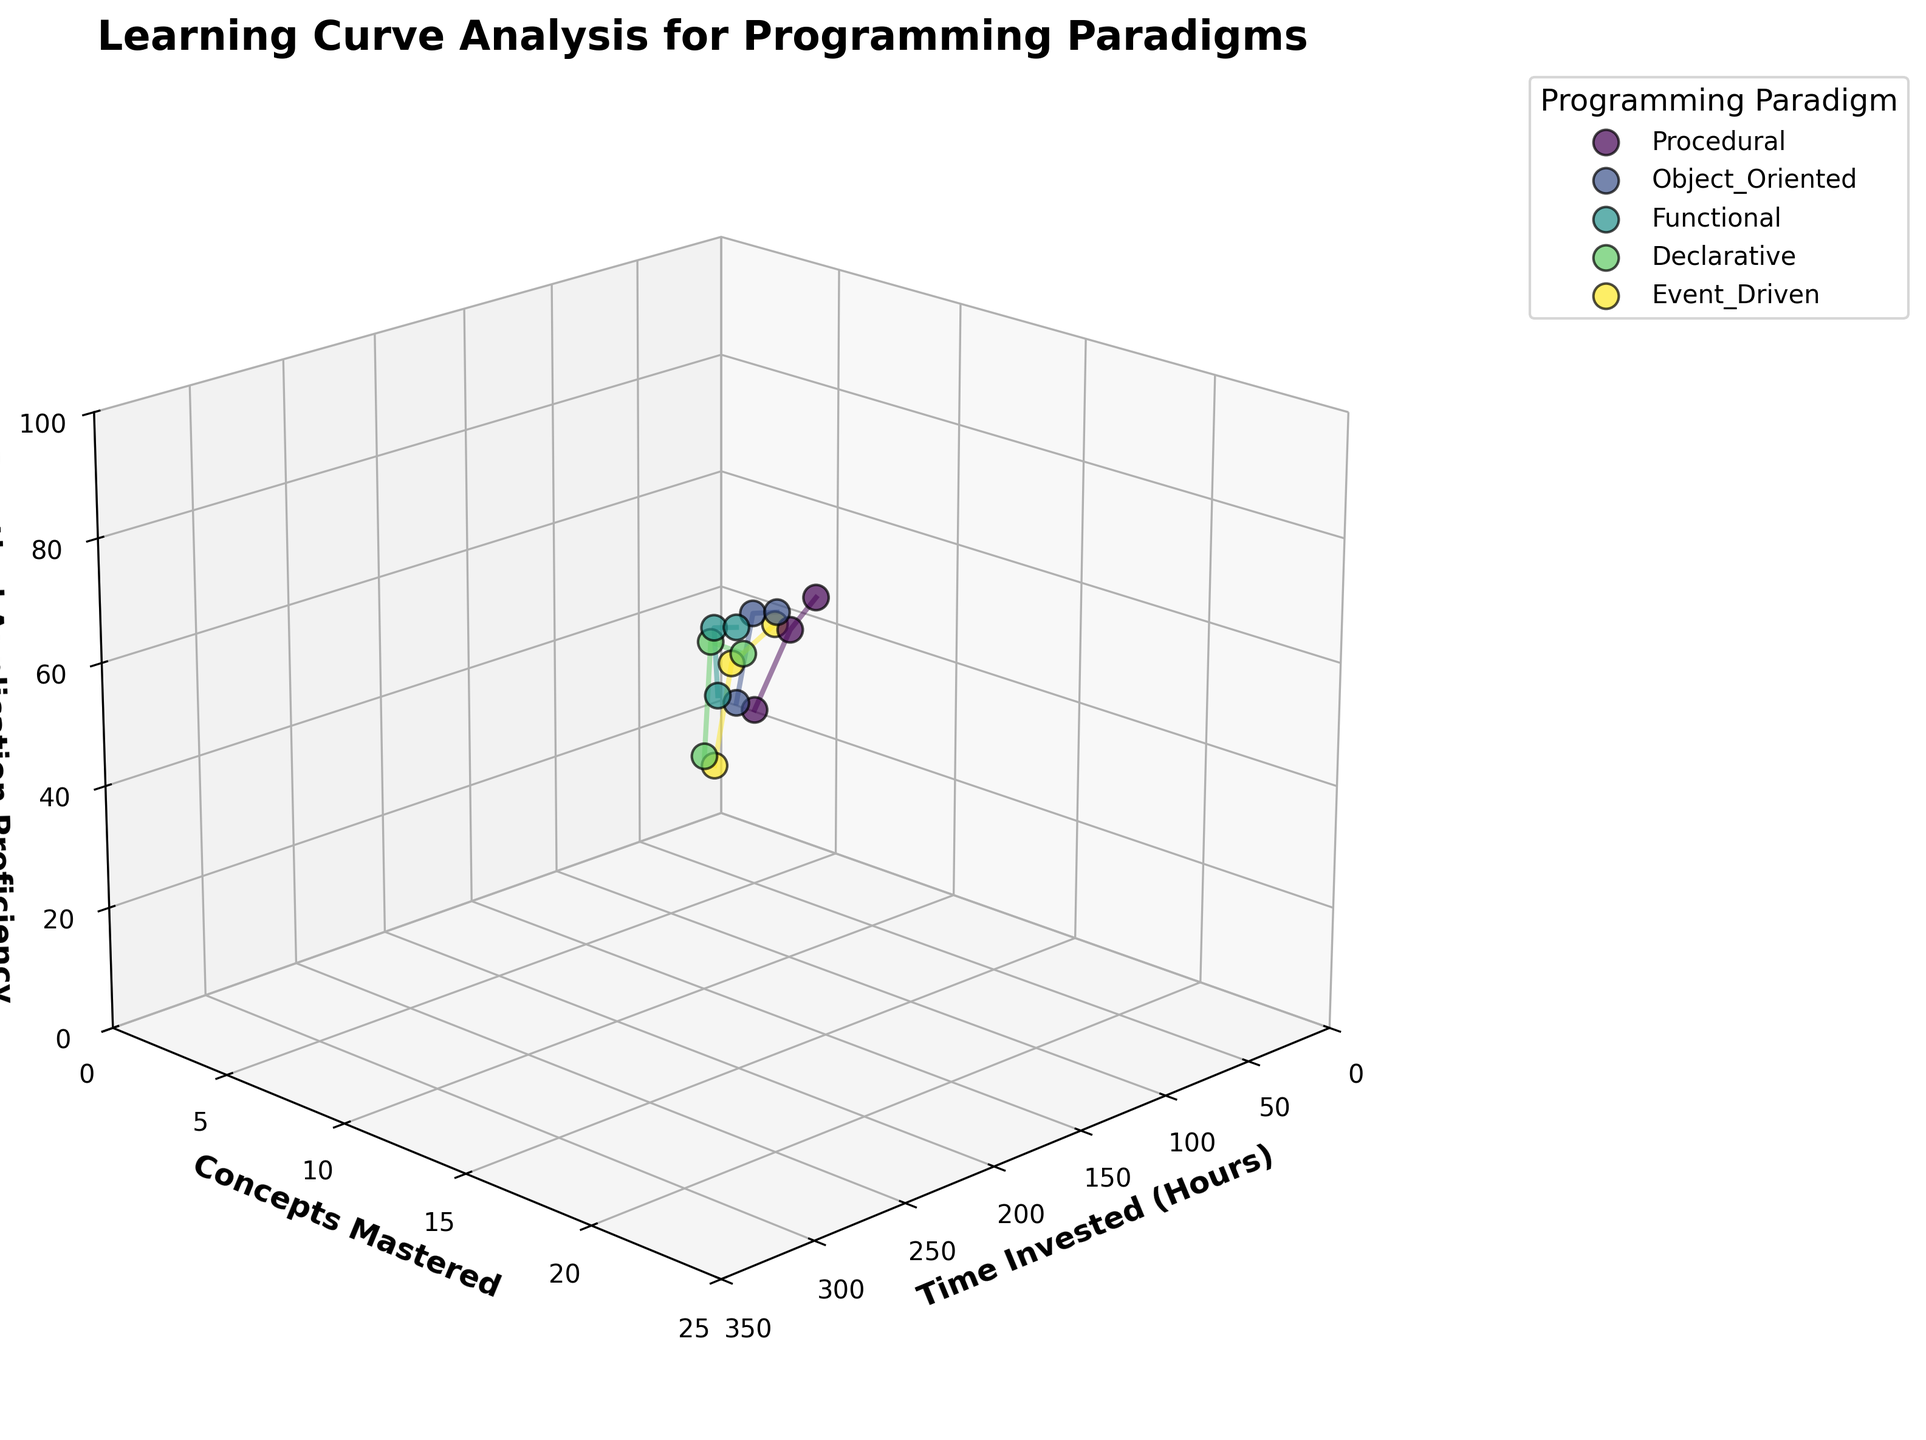What is the title of the figure? The title of the figure is displayed at the top of the 3D plot.
Answer: Learning Curve Analysis for Programming Paradigms What are the axis labels in the figure? The axes labels are displayed below and beside each axis. The x-axis is labeled "Time Invested (Hours)", the y-axis is labeled "Concepts Mastered", and the z-axis is labeled "Practical Application Proficiency".
Answer: Time Invested (Hours), Concepts Mastered, Practical Application Proficiency Which programming paradigm reached the highest practical application proficiency? Look at the z-axis values where the dots are positioned highest. The paradigm that reaches the highest value on this axis is the one with the highest practical application proficiency.
Answer: Functional How many data points are plotted for the Object-Oriented programming paradigm? Count the number of data points (or dots) associated with the Object-Oriented programming paradigm. Each dot represents a data point.
Answer: 3 What is the practical application proficiency for the Procedural paradigm when 100 hours are invested? Locate the Procedural paradigm data points and find the one that corresponds to 100 hours on the x-axis. Read the corresponding z-axis (Practical Application Proficiency) value.
Answer: 55 Compare the concepts mastered between the Declarative and Event-Driven paradigms at their final data points. Which paradigm mastered more concepts? Look at the final data point (highest x-axis value) for each paradigm and compare the y-axis (Concepts Mastered) values.
Answer: Declarative What is the difference in practical application proficiency between Functional and Procedural paradigms when 200 hours are invested? Identify the data points for Functional and Procedural paradigms at 200 hours on the x-axis and subtract the lower z-axis (Practical Application Proficiency) value from the higher one.
Answer: 10 (70 - 80) At which time investment point do both Object-Oriented and Event-Driven paradigms have equivalent concepts mastered? Find the data points where Object-Oriented and Event-Driven paradigms align in y-axis values and confirm the matching x-axis (Time Invested) value.
Answer: 120 hours Which programming paradigm shows the steepest increase in practical application proficiency? Examine the slopes formed by the lines connecting points for each paradigm. The steepest line indicates the most rapid increase in practical application proficiency.
Answer: Object-Oriented 